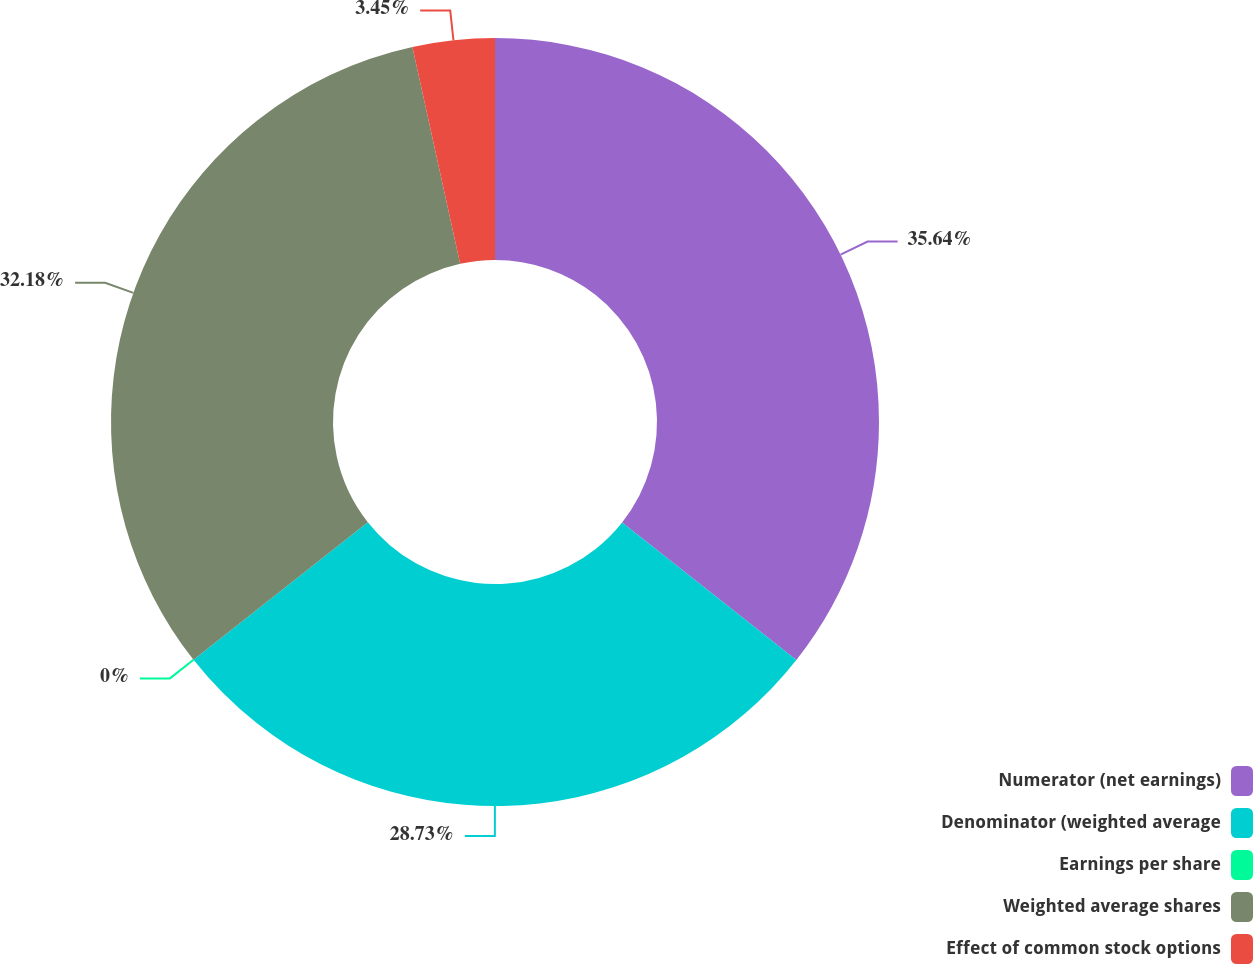Convert chart. <chart><loc_0><loc_0><loc_500><loc_500><pie_chart><fcel>Numerator (net earnings)<fcel>Denominator (weighted average<fcel>Earnings per share<fcel>Weighted average shares<fcel>Effect of common stock options<nl><fcel>35.64%<fcel>28.73%<fcel>0.0%<fcel>32.18%<fcel>3.45%<nl></chart> 